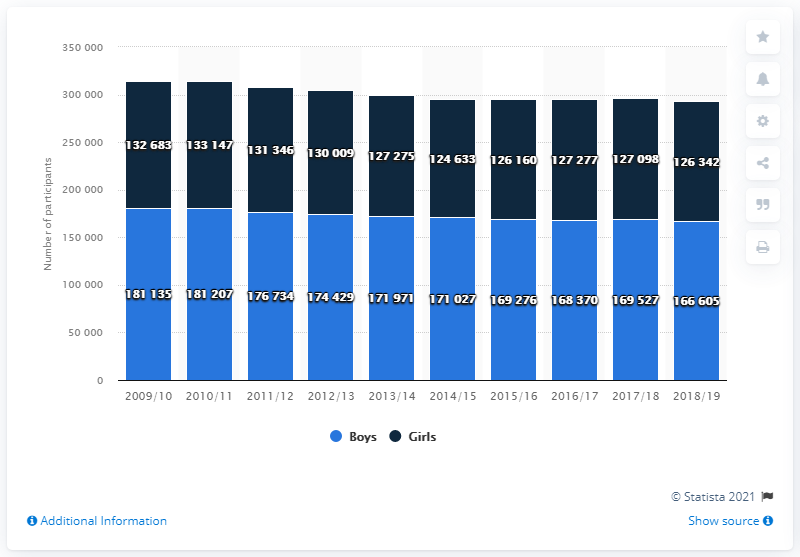How does the trend in participation change for boys from 2009/10 to 2018/19? The trend for boys' participation shows fluctuations over the years, starting at 132,683 in 2009/10 and experiencing a peak in 2011/12 at 183,207, before gradually declining to 166,605 by 2018/19. What could be the reason for the peak in 2011/12? Several factors could have contributed to the peak in 2011/12, including increased funding for youth sports programs, heightened public interest in specific events or sports, or demographic changes like increased youth population during that period. 